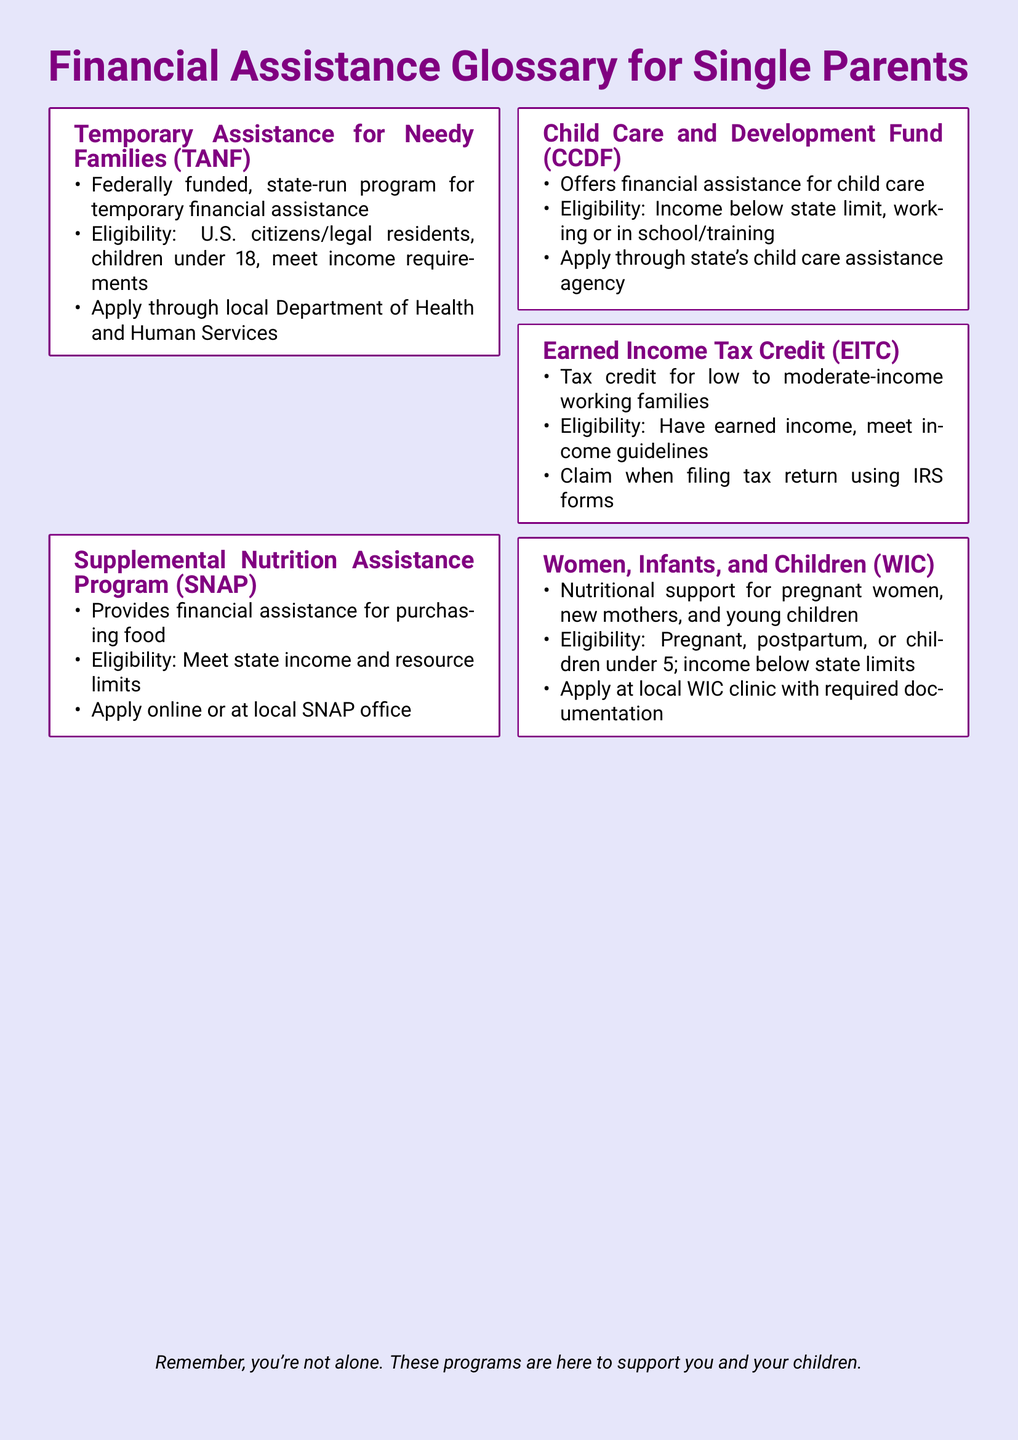What does TANF stand for? TANF stands for Temporary Assistance for Needy Families, which is defined in the document.
Answer: Temporary Assistance for Needy Families Who runs the TANF program? The document states that TANF is a federally funded, state-run program.
Answer: State-run What is the eligibility age for children under TANF? The document specifies that children under 18 are eligible for TANF.
Answer: Under 18 Where can one apply for SNAP? The document mentions that SNAP applications can be made online or at a local SNAP office.
Answer: Online or at local SNAP office What does WIC provide assistance for? The document states that WIC provides nutritional support for pregnant women, new mothers, and young children.
Answer: Nutritional support What is the EITC intended for? The document describes EITC as a tax credit for low to moderate-income working families.
Answer: Tax credit Which program is targeted specifically at child care assistance? The document identifies the Child Care and Development Fund (CCDF) as offering financial assistance for child care.
Answer: Child Care and Development Fund What is a common eligibility requirement for most programs? The document lists income limits as a common eligibility criterion across various programs.
Answer: Income limits What type of application process is mentioned for WIC? The document states that one must apply at a local WIC clinic with required documentation.
Answer: Apply at local WIC clinic 